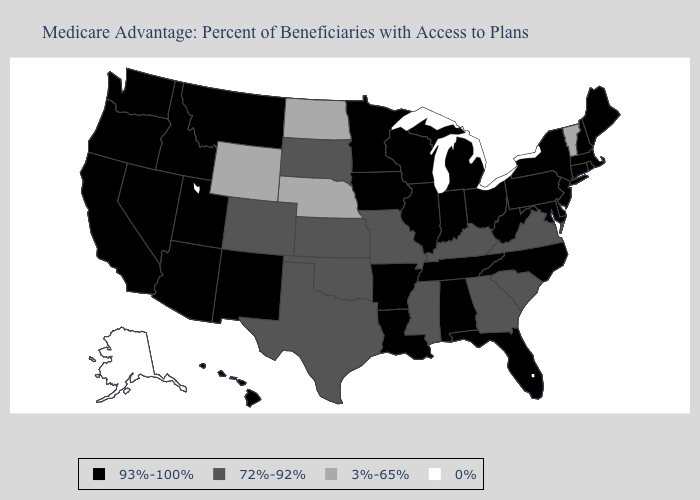Name the states that have a value in the range 93%-100%?
Concise answer only. California, Connecticut, Delaware, Florida, Hawaii, Iowa, Idaho, Illinois, Indiana, Louisiana, Massachusetts, Maryland, Maine, Michigan, Minnesota, Montana, North Carolina, New Hampshire, New Jersey, New Mexico, Nevada, New York, Ohio, Oregon, Pennsylvania, Rhode Island, Tennessee, Utah, Washington, Wisconsin, West Virginia, Alabama, Arkansas, Arizona. Does South Dakota have the highest value in the MidWest?
Keep it brief. No. Which states hav the highest value in the Northeast?
Be succinct. Connecticut, Massachusetts, Maine, New Hampshire, New Jersey, New York, Pennsylvania, Rhode Island. Does New Mexico have the lowest value in the USA?
Quick response, please. No. Name the states that have a value in the range 93%-100%?
Answer briefly. California, Connecticut, Delaware, Florida, Hawaii, Iowa, Idaho, Illinois, Indiana, Louisiana, Massachusetts, Maryland, Maine, Michigan, Minnesota, Montana, North Carolina, New Hampshire, New Jersey, New Mexico, Nevada, New York, Ohio, Oregon, Pennsylvania, Rhode Island, Tennessee, Utah, Washington, Wisconsin, West Virginia, Alabama, Arkansas, Arizona. What is the value of Rhode Island?
Short answer required. 93%-100%. What is the highest value in the USA?
Answer briefly. 93%-100%. Among the states that border Virginia , which have the lowest value?
Quick response, please. Kentucky. How many symbols are there in the legend?
Concise answer only. 4. What is the value of Washington?
Short answer required. 93%-100%. Name the states that have a value in the range 72%-92%?
Concise answer only. Colorado, Georgia, Kansas, Kentucky, Missouri, Mississippi, Oklahoma, South Carolina, South Dakota, Texas, Virginia. What is the highest value in the West ?
Give a very brief answer. 93%-100%. Does Wisconsin have the lowest value in the USA?
Write a very short answer. No. Name the states that have a value in the range 72%-92%?
Short answer required. Colorado, Georgia, Kansas, Kentucky, Missouri, Mississippi, Oklahoma, South Carolina, South Dakota, Texas, Virginia. What is the value of Hawaii?
Short answer required. 93%-100%. 